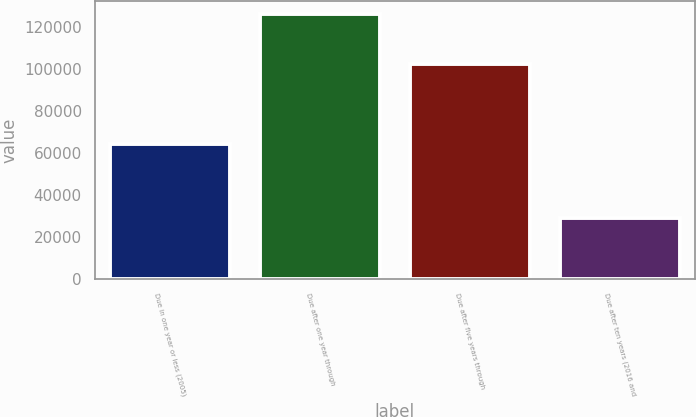<chart> <loc_0><loc_0><loc_500><loc_500><bar_chart><fcel>Due in one year or less (2005)<fcel>Due after one year through<fcel>Due after five years through<fcel>Due after ten years (2016 and<nl><fcel>64367<fcel>126017<fcel>102448<fcel>29383<nl></chart> 